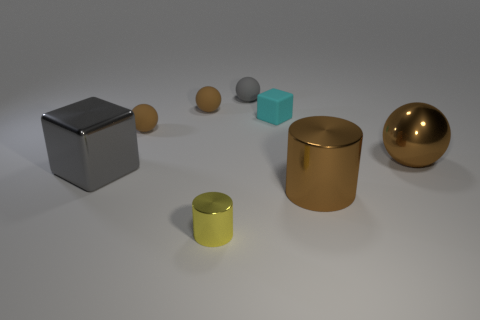What number of large objects are brown matte balls or brown shiny balls?
Offer a terse response. 1. Is the material of the gray object behind the brown metal ball the same as the small cube?
Keep it short and to the point. Yes. What shape is the brown thing that is behind the block to the right of the cylinder that is to the left of the small gray ball?
Provide a succinct answer. Sphere. What number of gray objects are either small metal cylinders or small rubber balls?
Your answer should be compact. 1. Are there an equal number of cyan objects that are to the right of the big ball and big things that are on the right side of the cyan thing?
Keep it short and to the point. No. Does the big gray object behind the big brown shiny cylinder have the same shape as the rubber thing that is in front of the tiny rubber cube?
Provide a short and direct response. No. Are there any other things that have the same shape as the gray matte object?
Keep it short and to the point. Yes. The small cyan object that is made of the same material as the gray sphere is what shape?
Offer a very short reply. Cube. Are there the same number of brown matte balls in front of the gray cube and big purple cylinders?
Ensure brevity in your answer.  Yes. Is the material of the big brown thing behind the gray block the same as the large object that is left of the brown cylinder?
Keep it short and to the point. Yes. 